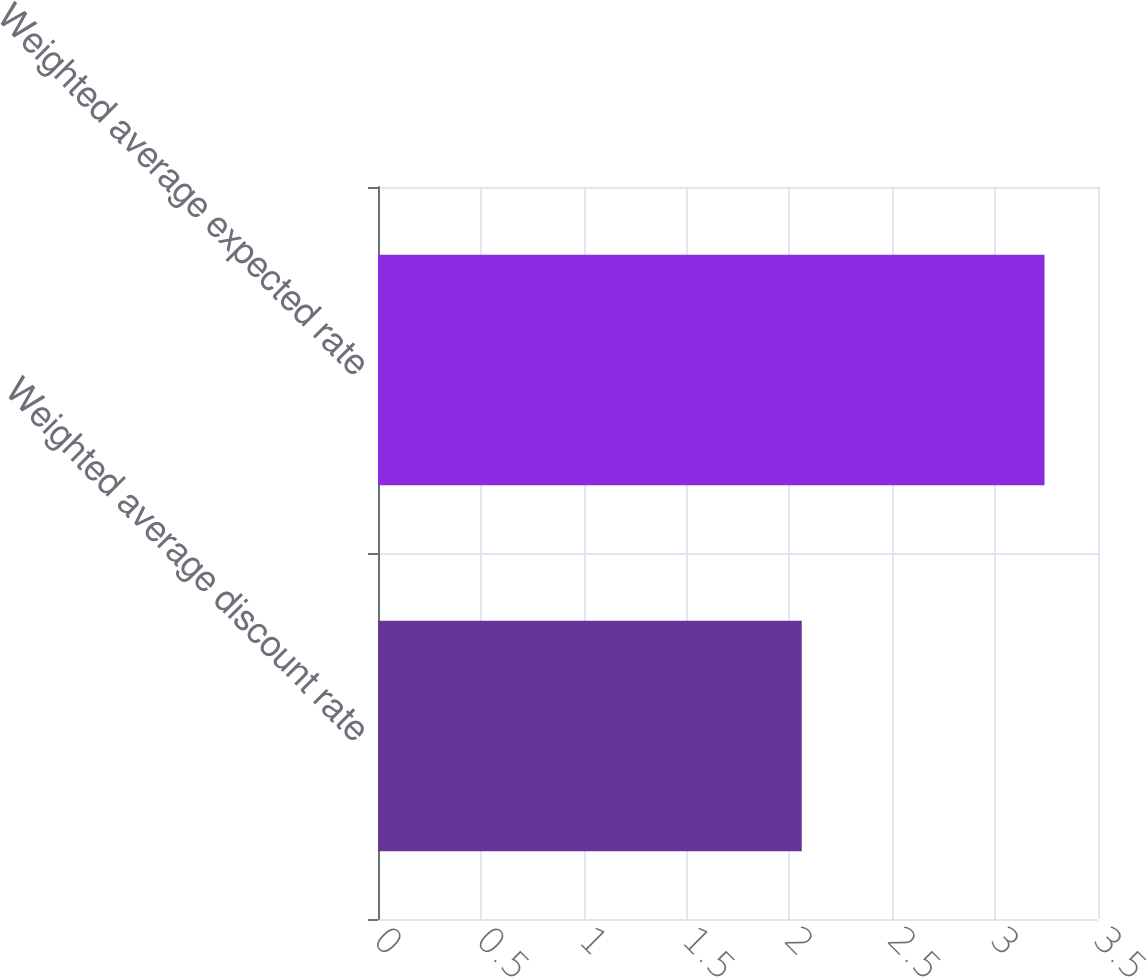Convert chart to OTSL. <chart><loc_0><loc_0><loc_500><loc_500><bar_chart><fcel>Weighted average discount rate<fcel>Weighted average expected rate<nl><fcel>2.06<fcel>3.24<nl></chart> 